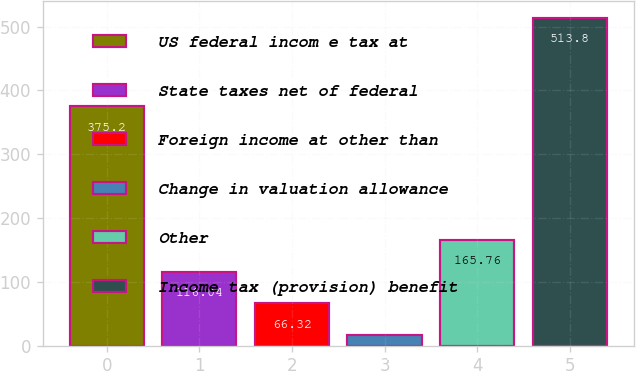Convert chart to OTSL. <chart><loc_0><loc_0><loc_500><loc_500><bar_chart><fcel>US federal incom e tax at<fcel>State taxes net of federal<fcel>Foreign income at other than<fcel>Change in valuation allowance<fcel>Other<fcel>Income tax (provision) benefit<nl><fcel>375.2<fcel>116.04<fcel>66.32<fcel>16.6<fcel>165.76<fcel>513.8<nl></chart> 